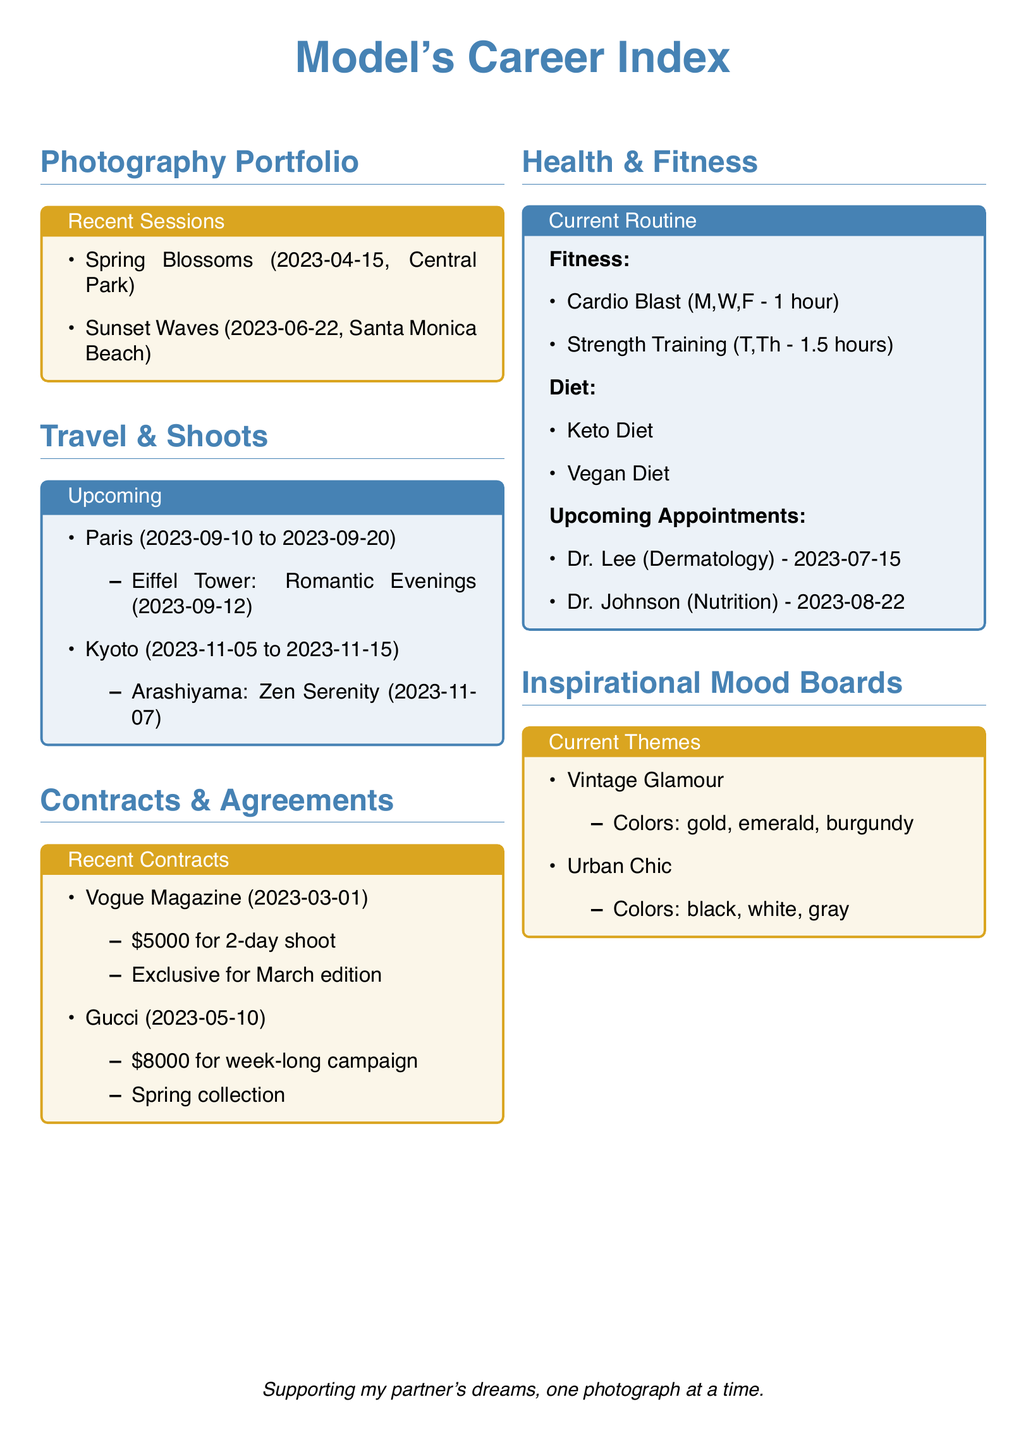What is the theme of the April 2023 photo session? The theme for the session on April 15, 2023, is listed as Spring Blossoms.
Answer: Spring Blossoms When is the scheduled photo shoot in Paris? The scheduled photo shoot in Paris is detailed on September 12, 2023.
Answer: September 12, 2023 How much is the payment for the Gucci contract? The Gucci contract specifies a payment of $8000 for a week-long campaign.
Answer: $8000 What dietary plans are mentioned in the health section? The health section lists both Keto Diet and Vegan Diet under diet plans.
Answer: Keto Diet, Vegan Diet What are the colors listed for the Urban Chic mood board? The Urban Chic mood board features colors black, white, and gray.
Answer: black, white, gray How many hours is the cardio routine scheduled per week? The cardio routine is scheduled for 1 hour on Monday, Wednesday, and Friday, totaling 3 hours a week.
Answer: 3 hours What is the date of the upcoming appointment with Dr. Johnson? The upcoming appointment with Dr. Johnson is on August 22, 2023.
Answer: August 22, 2023 What is the title of the recent shoot in Santa Monica Beach? The title of the shoot in Santa Monica Beach is Sunset Waves.
Answer: Sunset Waves Which theme includes emerald and burgundy colors? The theme that includes emerald and burgundy colors is Vintage Glamour.
Answer: Vintage Glamour 